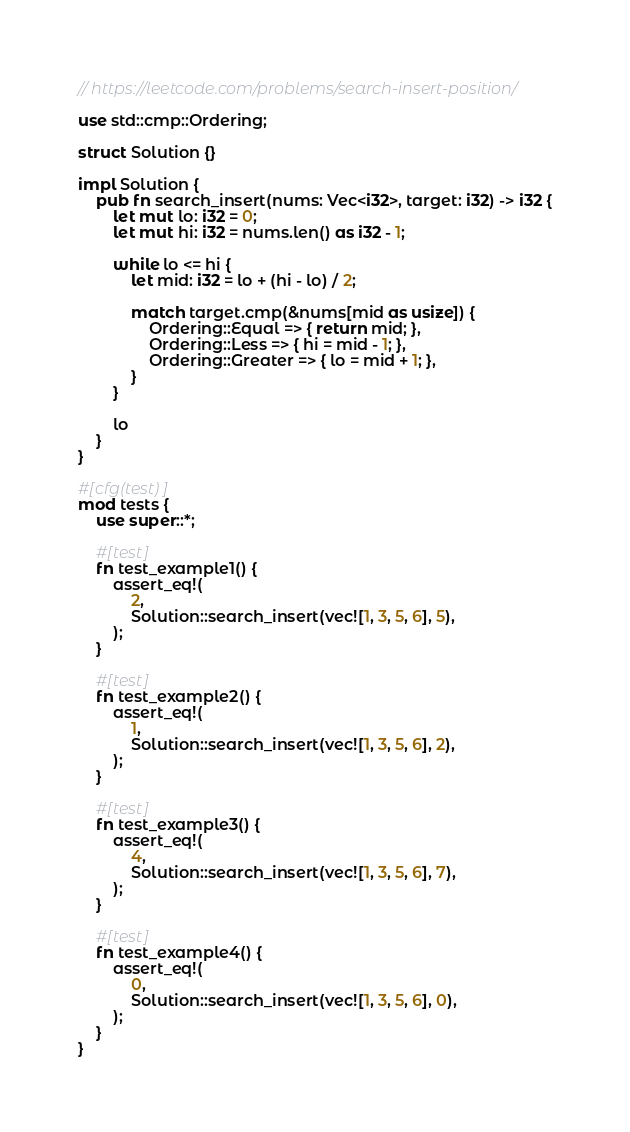Convert code to text. <code><loc_0><loc_0><loc_500><loc_500><_Rust_>// https://leetcode.com/problems/search-insert-position/

use std::cmp::Ordering;

struct Solution {}

impl Solution {
    pub fn search_insert(nums: Vec<i32>, target: i32) -> i32 {
        let mut lo: i32 = 0;
        let mut hi: i32 = nums.len() as i32 - 1;

        while lo <= hi {
            let mid: i32 = lo + (hi - lo) / 2;

            match target.cmp(&nums[mid as usize]) {
                Ordering::Equal => { return mid; },
                Ordering::Less => { hi = mid - 1; },
                Ordering::Greater => { lo = mid + 1; },
            }
        }

        lo
    }
}

#[cfg(test)]
mod tests {
    use super::*;

    #[test]
    fn test_example1() {
        assert_eq!(
            2,
            Solution::search_insert(vec![1, 3, 5, 6], 5),
        );
    }

    #[test]
    fn test_example2() {
        assert_eq!(
            1,
            Solution::search_insert(vec![1, 3, 5, 6], 2),
        );
    }

    #[test]
    fn test_example3() {
        assert_eq!(
            4,
            Solution::search_insert(vec![1, 3, 5, 6], 7),
        );
    }

    #[test]
    fn test_example4() {
        assert_eq!(
            0,
            Solution::search_insert(vec![1, 3, 5, 6], 0),
        );
    }
}
</code> 